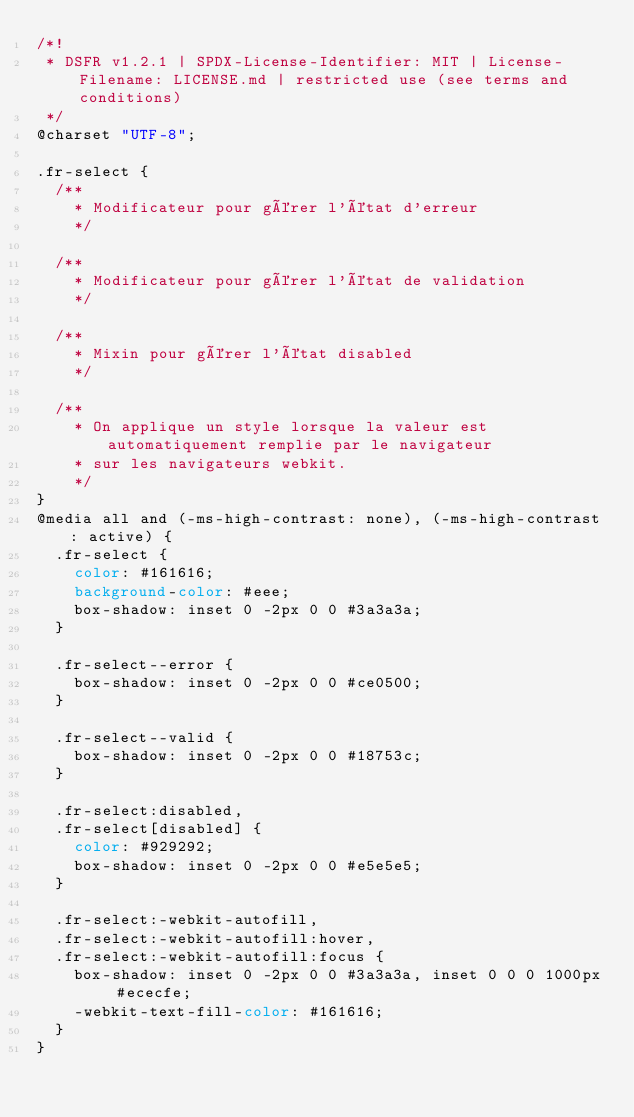Convert code to text. <code><loc_0><loc_0><loc_500><loc_500><_CSS_>/*!
 * DSFR v1.2.1 | SPDX-License-Identifier: MIT | License-Filename: LICENSE.md | restricted use (see terms and conditions)
 */
@charset "UTF-8";

.fr-select {
  /**
    * Modificateur pour gérer l'état d'erreur
    */

  /**
    * Modificateur pour gérer l'état de validation
    */

  /**
    * Mixin pour gérer l'état disabled
    */

  /**
    * On applique un style lorsque la valeur est automatiquement remplie par le navigateur
    * sur les navigateurs webkit.
    */
}
@media all and (-ms-high-contrast: none), (-ms-high-contrast: active) {
  .fr-select {
    color: #161616;
    background-color: #eee;
    box-shadow: inset 0 -2px 0 0 #3a3a3a;
  }

  .fr-select--error {
    box-shadow: inset 0 -2px 0 0 #ce0500;
  }

  .fr-select--valid {
    box-shadow: inset 0 -2px 0 0 #18753c;
  }

  .fr-select:disabled,
  .fr-select[disabled] {
    color: #929292;
    box-shadow: inset 0 -2px 0 0 #e5e5e5;
  }

  .fr-select:-webkit-autofill,
  .fr-select:-webkit-autofill:hover,
  .fr-select:-webkit-autofill:focus {
    box-shadow: inset 0 -2px 0 0 #3a3a3a, inset 0 0 0 1000px #ececfe;
    -webkit-text-fill-color: #161616;
  }
}
</code> 